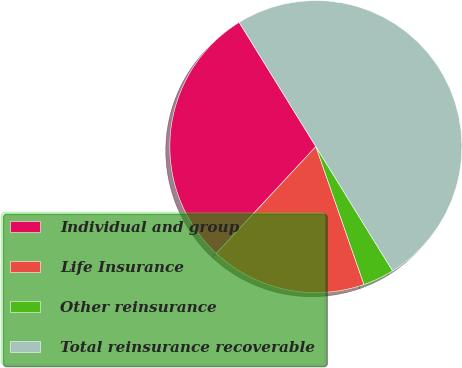Convert chart. <chart><loc_0><loc_0><loc_500><loc_500><pie_chart><fcel>Individual and group<fcel>Life Insurance<fcel>Other reinsurance<fcel>Total reinsurance recoverable<nl><fcel>29.26%<fcel>17.28%<fcel>3.46%<fcel>50.0%<nl></chart> 